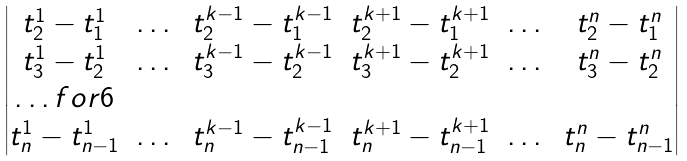Convert formula to latex. <formula><loc_0><loc_0><loc_500><loc_500>\begin{vmatrix} t _ { 2 } ^ { 1 } - t _ { 1 } ^ { 1 } & \dots & t _ { 2 } ^ { k - 1 } - t _ { 1 } ^ { k - 1 } & t _ { 2 } ^ { k + 1 } - t _ { 1 } ^ { k + 1 } & \dots & t _ { 2 } ^ { n } - t _ { 1 } ^ { n } \\ t _ { 3 } ^ { 1 } - t _ { 2 } ^ { 1 } & \dots & t _ { 3 } ^ { k - 1 } - t _ { 2 } ^ { k - 1 } & t _ { 3 } ^ { k + 1 } - t _ { 2 } ^ { k + 1 } & \dots & t _ { 3 } ^ { n } - t _ { 2 } ^ { n } \\ \hdots f o r { 6 } \\ t _ { n } ^ { 1 } - t _ { n - 1 } ^ { 1 } & \dots & t _ { n } ^ { k - 1 } - t _ { n - 1 } ^ { k - 1 } & t _ { n } ^ { k + 1 } - t _ { n - 1 } ^ { k + 1 } & \dots & t _ { n } ^ { n } - t _ { n - 1 } ^ { n } \end{vmatrix}</formula> 